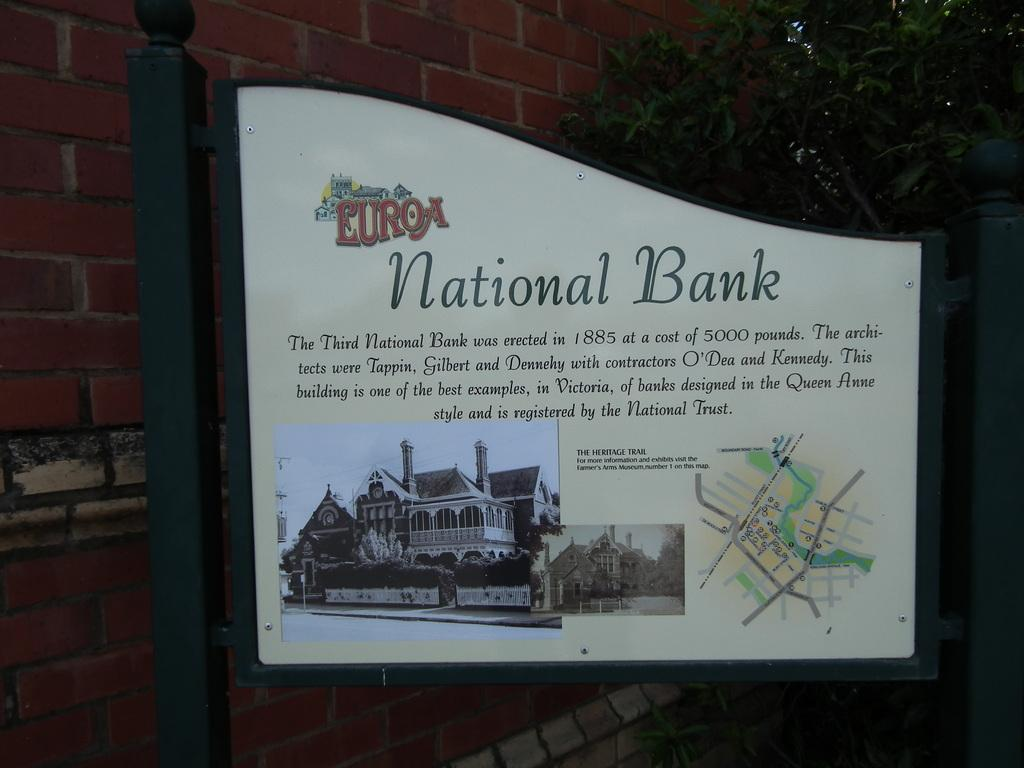<image>
Give a short and clear explanation of the subsequent image. A small sign of a national bank on a post outside of a building. 